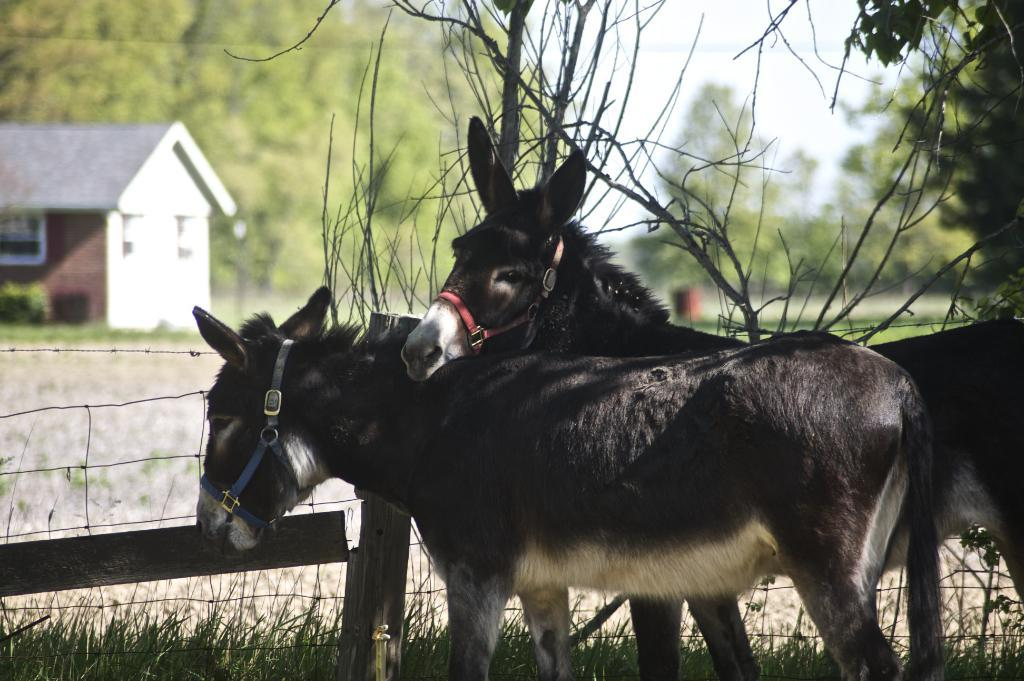How many donkeys are present in the image? There are two donkeys in the image. What is the terrain where the donkeys are standing? The donkeys are standing on grassland. How many crows are sitting on the donkeys in the image? There are no crows present in the image; it only features two donkeys. What type of group is formed by the donkeys in the image? The image does not depict a group; it shows two individual donkeys. 